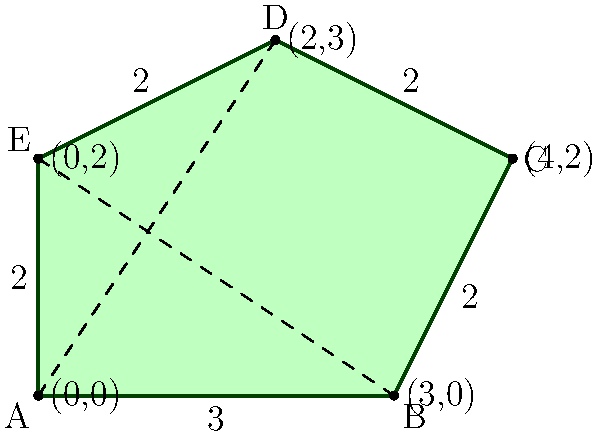As a clothing manufacturer focused on sustainability, you want to maximize material utilization. You have an irregularly shaped fabric piece as shown in the diagram. The shape is formed by connecting points A(0,0), B(3,0), C(4,2), D(2,3), and E(0,2). Calculate the area of this fabric piece to determine how much material you can use for garment construction. To calculate the area of this irregular shape, we can divide it into triangles and use the formula for the area of a triangle: $A = \frac{1}{2} \times base \times height$.

1. Divide the shape into three triangles: ABC, ACD, and ADE.

2. Calculate the area of triangle ABC:
   Base (AB) = 3, Height (perpendicular from C to AB) = 2
   $A_{ABC} = \frac{1}{2} \times 3 \times 2 = 3$ square units

3. Calculate the area of triangle ACD:
   Base (AD) = $\sqrt{2^2 + 3^2} = \sqrt{13}$, Height (perpendicular from C to AD) = $\frac{3 \times 2}{\sqrt{13}} = \frac{6}{\sqrt{13}}$
   $A_{ACD} = \frac{1}{2} \times \sqrt{13} \times \frac{6}{\sqrt{13}} = 3$ square units

4. Calculate the area of triangle ADE:
   Base (AE) = 2, Height (perpendicular from D to AE) = 1
   $A_{ADE} = \frac{1}{2} \times 2 \times 1 = 1$ square unit

5. Sum up the areas of all triangles:
   $A_{total} = A_{ABC} + A_{ACD} + A_{ADE} = 3 + 3 + 1 = 7$ square units

Therefore, the total area of the fabric piece is 7 square units.
Answer: 7 square units 